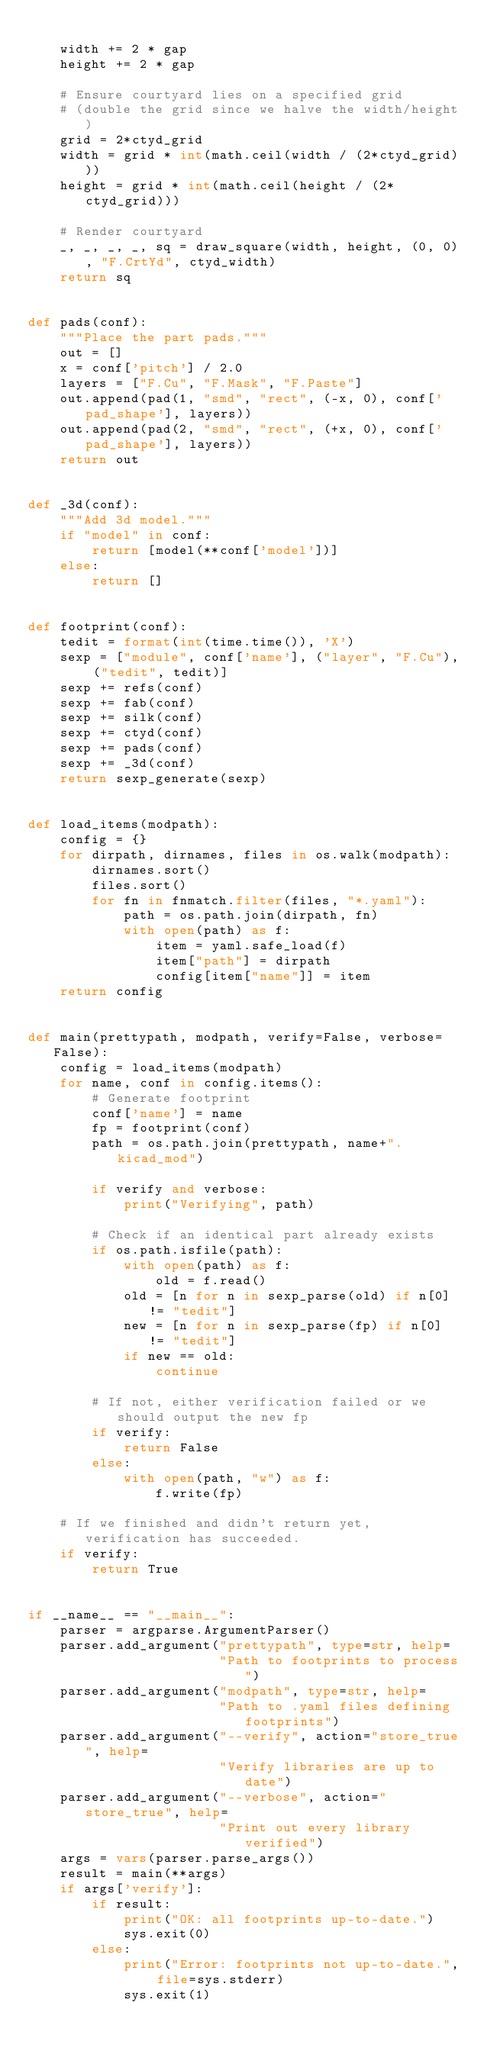Convert code to text. <code><loc_0><loc_0><loc_500><loc_500><_Python_>
    width += 2 * gap
    height += 2 * gap

    # Ensure courtyard lies on a specified grid
    # (double the grid since we halve the width/height)
    grid = 2*ctyd_grid
    width = grid * int(math.ceil(width / (2*ctyd_grid)))
    height = grid * int(math.ceil(height / (2*ctyd_grid)))

    # Render courtyard
    _, _, _, _, sq = draw_square(width, height, (0, 0), "F.CrtYd", ctyd_width)
    return sq


def pads(conf):
    """Place the part pads."""
    out = []
    x = conf['pitch'] / 2.0
    layers = ["F.Cu", "F.Mask", "F.Paste"]
    out.append(pad(1, "smd", "rect", (-x, 0), conf['pad_shape'], layers))
    out.append(pad(2, "smd", "rect", (+x, 0), conf['pad_shape'], layers))
    return out


def _3d(conf):
    """Add 3d model."""
    if "model" in conf:
        return [model(**conf['model'])]
    else:
        return []


def footprint(conf):
    tedit = format(int(time.time()), 'X')
    sexp = ["module", conf['name'], ("layer", "F.Cu"), ("tedit", tedit)]
    sexp += refs(conf)
    sexp += fab(conf)
    sexp += silk(conf)
    sexp += ctyd(conf)
    sexp += pads(conf)
    sexp += _3d(conf)
    return sexp_generate(sexp)


def load_items(modpath):
    config = {}
    for dirpath, dirnames, files in os.walk(modpath):
        dirnames.sort()
        files.sort()
        for fn in fnmatch.filter(files, "*.yaml"):
            path = os.path.join(dirpath, fn)
            with open(path) as f:
                item = yaml.safe_load(f)
                item["path"] = dirpath
                config[item["name"]] = item
    return config


def main(prettypath, modpath, verify=False, verbose=False):
    config = load_items(modpath)
    for name, conf in config.items():
        # Generate footprint
        conf['name'] = name
        fp = footprint(conf)
        path = os.path.join(prettypath, name+".kicad_mod")

        if verify and verbose:
            print("Verifying", path)

        # Check if an identical part already exists
        if os.path.isfile(path):
            with open(path) as f:
                old = f.read()
            old = [n for n in sexp_parse(old) if n[0] != "tedit"]
            new = [n for n in sexp_parse(fp) if n[0] != "tedit"]
            if new == old:
                continue

        # If not, either verification failed or we should output the new fp
        if verify:
            return False
        else:
            with open(path, "w") as f:
                f.write(fp)

    # If we finished and didn't return yet, verification has succeeded.
    if verify:
        return True


if __name__ == "__main__":
    parser = argparse.ArgumentParser()
    parser.add_argument("prettypath", type=str, help=
                        "Path to footprints to process")
    parser.add_argument("modpath", type=str, help=
                        "Path to .yaml files defining footprints")
    parser.add_argument("--verify", action="store_true", help=
                        "Verify libraries are up to date")
    parser.add_argument("--verbose", action="store_true", help=
                        "Print out every library verified")
    args = vars(parser.parse_args())
    result = main(**args)
    if args['verify']:
        if result:
            print("OK: all footprints up-to-date.")
            sys.exit(0)
        else:
            print("Error: footprints not up-to-date.", file=sys.stderr)
            sys.exit(1)
</code> 